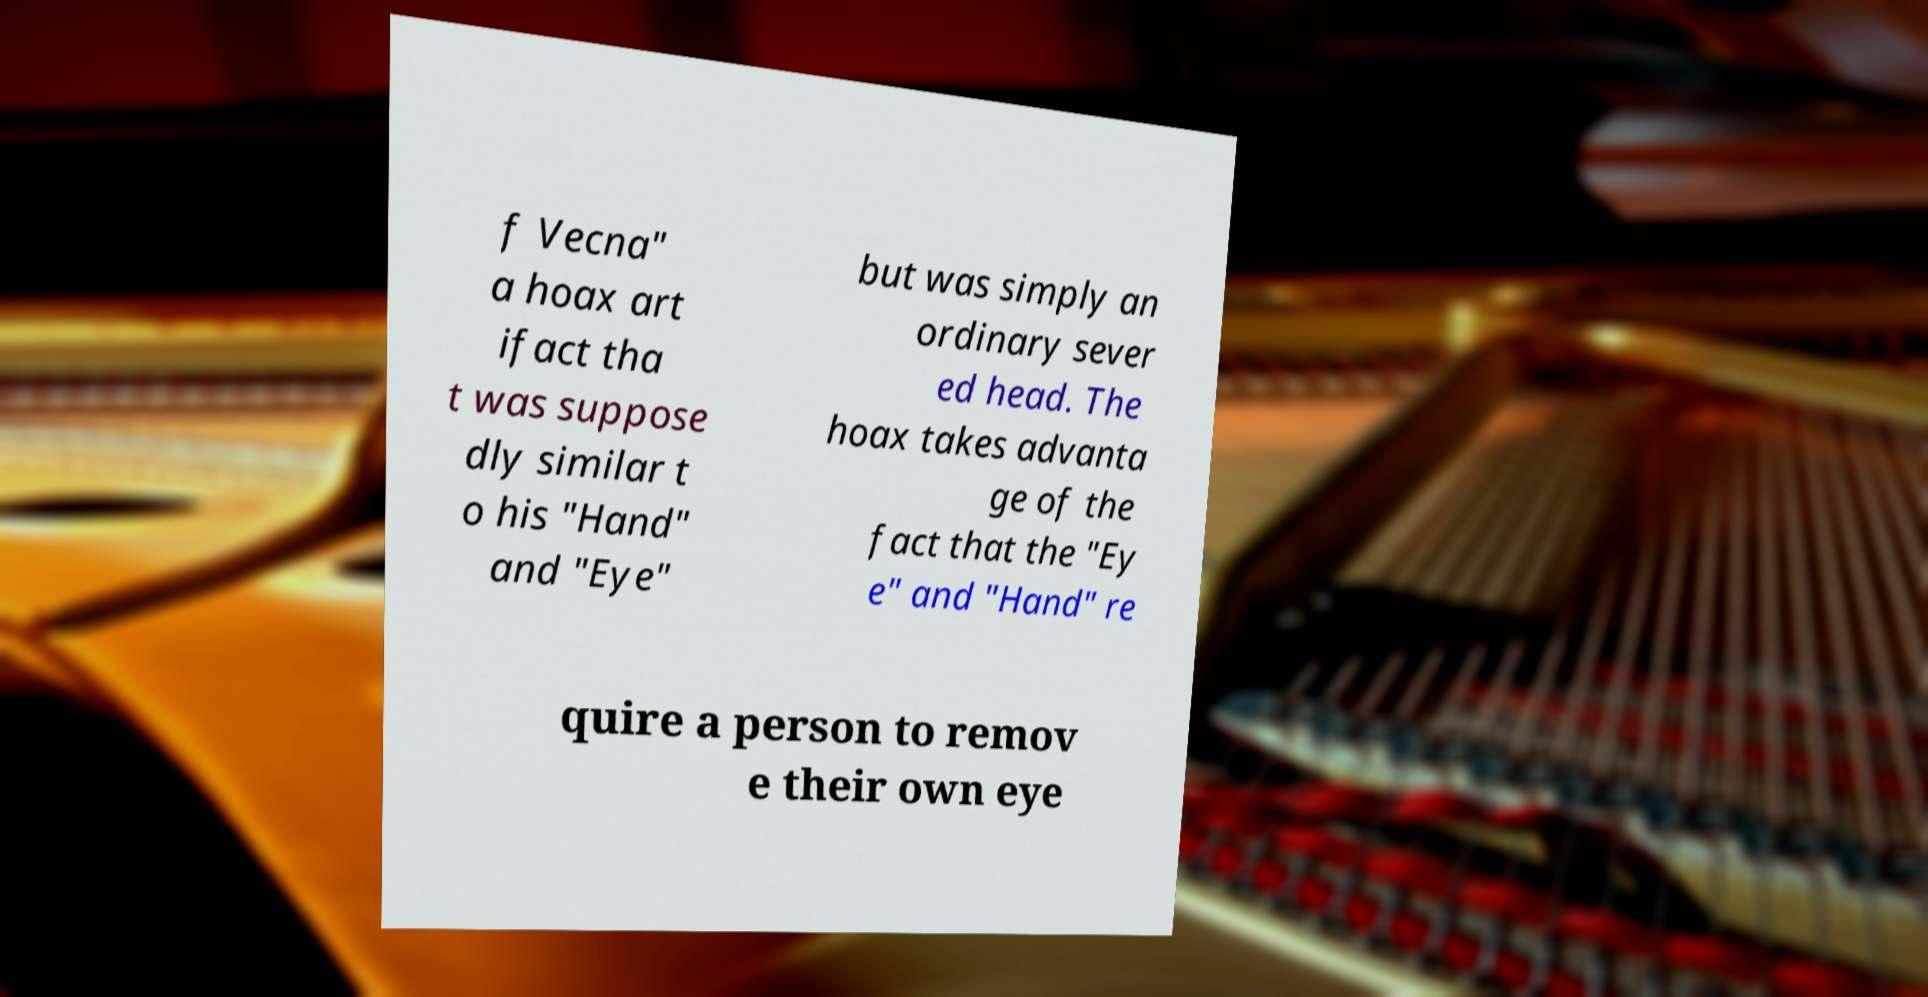What messages or text are displayed in this image? I need them in a readable, typed format. f Vecna" a hoax art ifact tha t was suppose dly similar t o his "Hand" and "Eye" but was simply an ordinary sever ed head. The hoax takes advanta ge of the fact that the "Ey e" and "Hand" re quire a person to remov e their own eye 